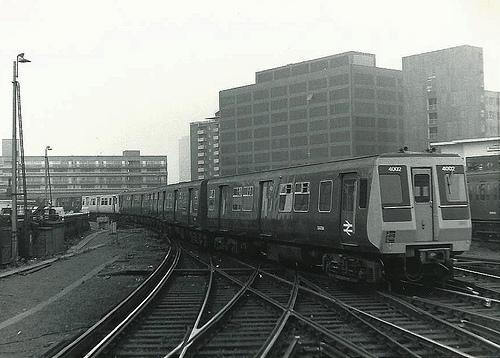Question: how many trains are there?
Choices:
A. One.
B. Two.
C. Three.
D. None.
Answer with the letter. Answer: D Question: who is in the photo?
Choices:
A. One person.
B. Three people.
C. Nobody.
D. Two people.
Answer with the letter. Answer: C Question: how many people are in the photo?
Choices:
A. One.
B. None.
C. Two.
D. Three.
Answer with the letter. Answer: B Question: where was this photo taken?
Choices:
A. From a bus stop.
B. From a train station.
C. From an airport.
D. From an island.
Answer with the letter. Answer: B Question: what kind of photo is this?
Choices:
A. Color.
B. Black and white.
C. Blurry.
D. Grainy.
Answer with the letter. Answer: B Question: what is on the track?
Choices:
A. A bus.
B. A train.
C. A car.
D. A bike.
Answer with the letter. Answer: B 